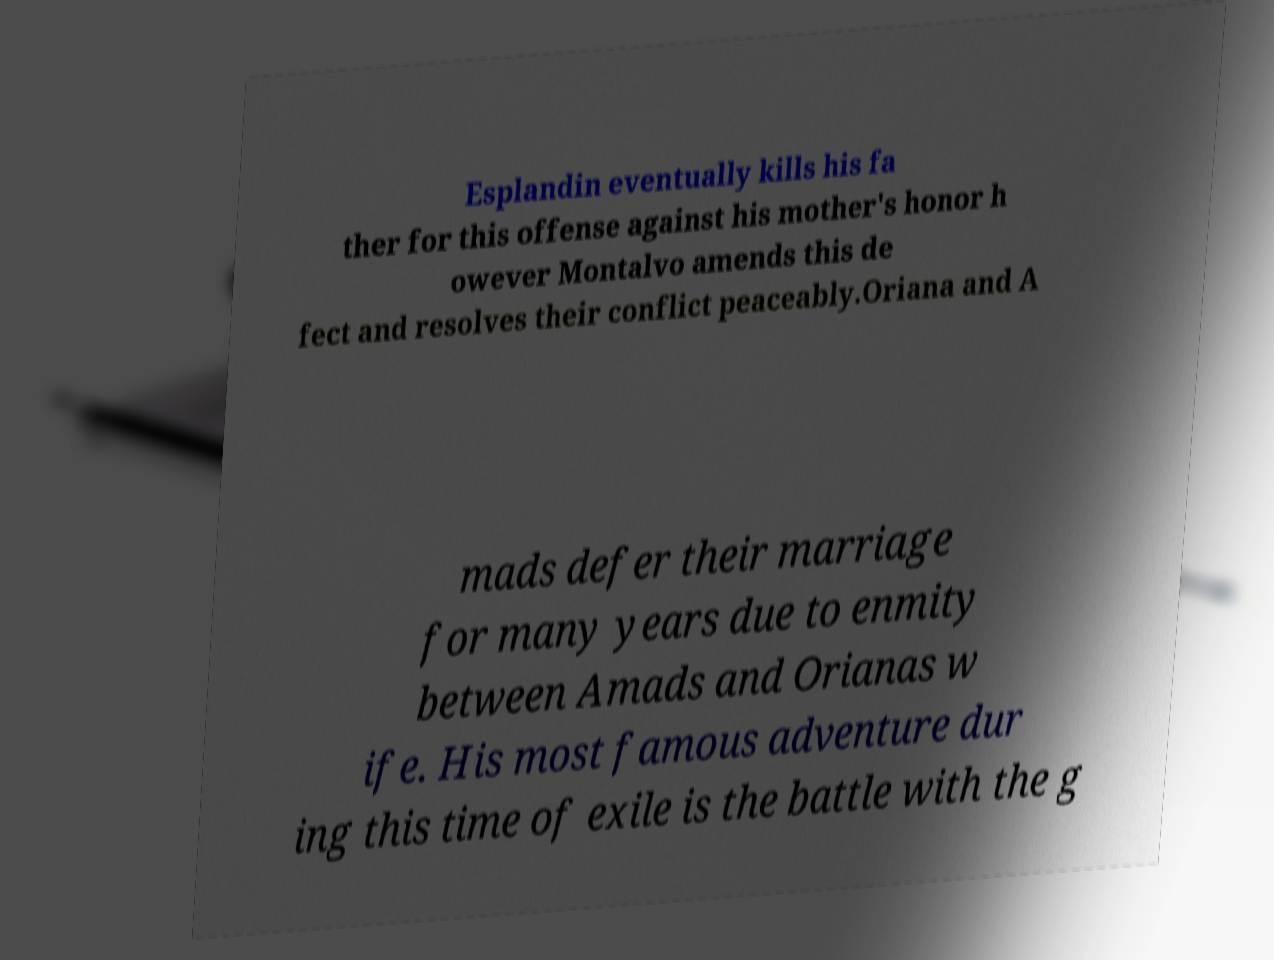For documentation purposes, I need the text within this image transcribed. Could you provide that? Esplandin eventually kills his fa ther for this offense against his mother's honor h owever Montalvo amends this de fect and resolves their conflict peaceably.Oriana and A mads defer their marriage for many years due to enmity between Amads and Orianas w ife. His most famous adventure dur ing this time of exile is the battle with the g 